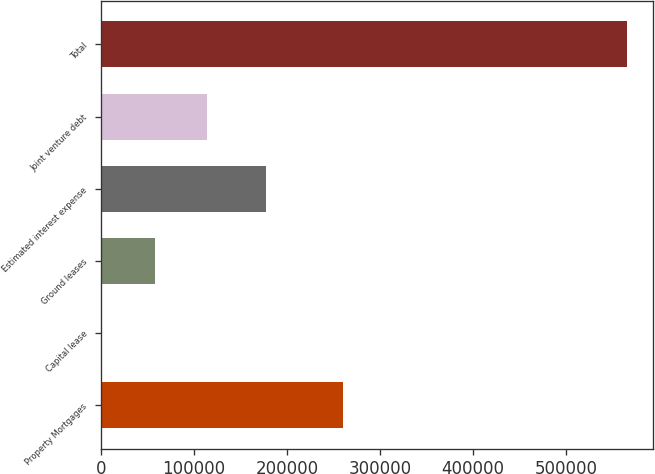Convert chart. <chart><loc_0><loc_0><loc_500><loc_500><bar_chart><fcel>Property Mortgages<fcel>Capital lease<fcel>Ground leases<fcel>Estimated interest expense<fcel>Joint venture debt<fcel>Total<nl><fcel>260433<fcel>1593<fcel>57955<fcel>177565<fcel>114317<fcel>565213<nl></chart> 